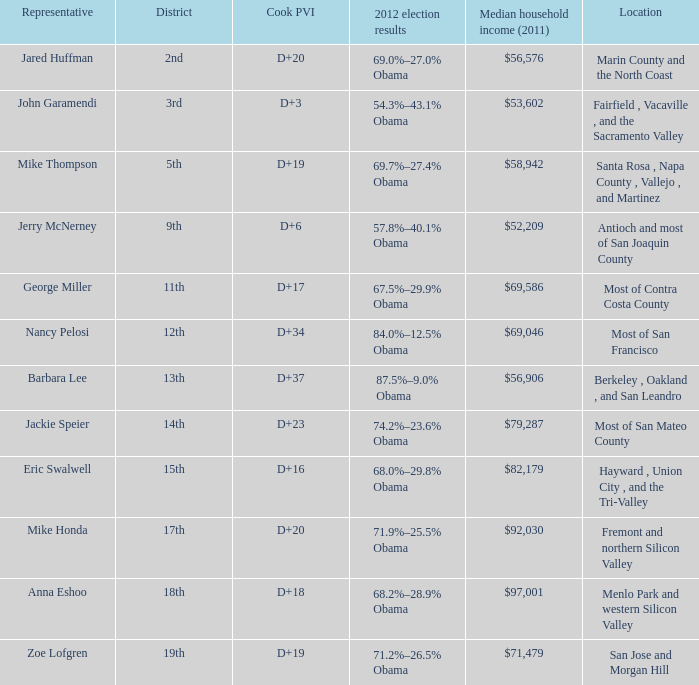What is the 2012 election results for locations whose representative is Barbara Lee? 87.5%–9.0% Obama. 